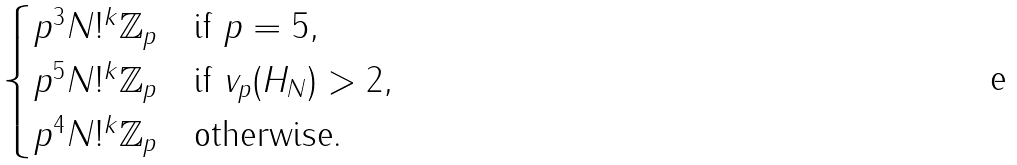Convert formula to latex. <formula><loc_0><loc_0><loc_500><loc_500>\begin{cases} p ^ { 3 } N ! ^ { k } \mathbb { Z } _ { p } & \text {if } p = 5 , \\ p ^ { 5 } N ! ^ { k } \mathbb { Z } _ { p } & \text {if } v _ { p } ( H _ { N } ) > 2 , \\ p ^ { 4 } N ! ^ { k } \mathbb { Z } _ { p } & \text {otherwise.} \end{cases}</formula> 